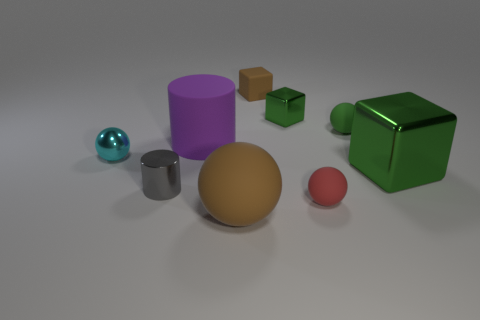Are there any big things behind the green shiny object in front of the green metal object behind the big purple rubber thing?
Make the answer very short. Yes. Is the number of brown rubber balls behind the small green shiny thing greater than the number of green shiny things that are in front of the large green block?
Provide a short and direct response. No. There is a ball that is the same size as the purple matte thing; what is its material?
Offer a terse response. Rubber. What number of large things are either spheres or green shiny cubes?
Provide a short and direct response. 2. Does the small gray shiny object have the same shape as the purple thing?
Your answer should be very brief. Yes. What number of small spheres are on the left side of the purple rubber object and in front of the cyan sphere?
Your answer should be compact. 0. Are there any other things that have the same color as the big cylinder?
Your answer should be very brief. No. What shape is the small gray thing that is made of the same material as the tiny cyan sphere?
Give a very brief answer. Cylinder. Does the green matte thing have the same size as the gray thing?
Keep it short and to the point. Yes. Are the brown thing that is behind the big brown thing and the gray thing made of the same material?
Offer a terse response. No. 